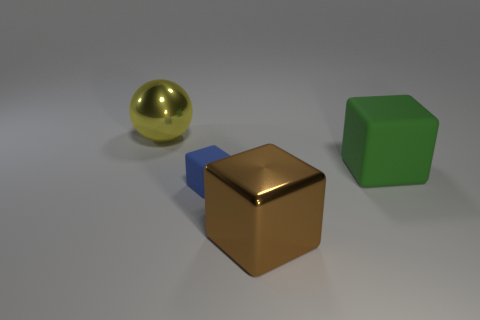Add 2 tiny blue rubber spheres. How many objects exist? 6 Subtract all balls. How many objects are left? 3 Subtract all big brown metal things. Subtract all small blue blocks. How many objects are left? 2 Add 2 metallic spheres. How many metallic spheres are left? 3 Add 3 small cyan metallic cubes. How many small cyan metallic cubes exist? 3 Subtract 1 brown blocks. How many objects are left? 3 